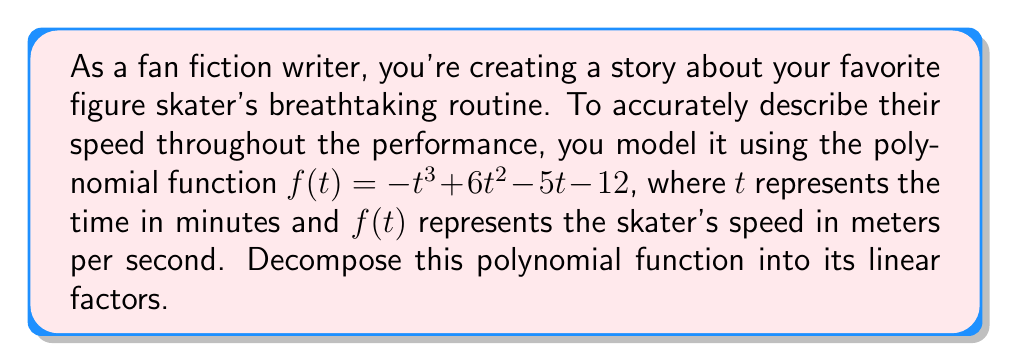Can you answer this question? To decompose the polynomial function $f(t) = -t^3 + 6t^2 - 5t - 12$ into its linear factors, we'll follow these steps:

1) First, let's check if there are any rational roots using the rational root theorem. The possible rational roots are the factors of the constant term: $\pm 1, \pm 2, \pm 3, \pm 4, \pm 6, \pm 12$.

2) Testing these values, we find that $t = 4$ is a root of the polynomial. So $(t - 4)$ is a factor.

3) We can use polynomial long division to divide $f(t)$ by $(t - 4)$:

   $$-t^3 + 6t^2 - 5t - 12 = (t - 4)(-t^2 + 2t + 3)$$

4) Now we need to factor the quadratic $-t^2 + 2t + 3$. We can do this by finding its roots:

   $$t = \frac{-b \pm \sqrt{b^2 - 4ac}}{2a} = \frac{-2 \pm \sqrt{4 + 12}}{-2} = \frac{-2 \pm \sqrt{16}}{-2} = \frac{-2 \pm 4}{-2}$$

5) This gives us the roots $t = 3$ and $t = -1$. Therefore, $-t^2 + 2t + 3 = -(t - 3)(t + 1)$.

6) Putting it all together:

   $$f(t) = -t^3 + 6t^2 - 5t - 12 = -(t - 4)(t - 3)(t + 1)$$

Thus, we have decomposed the polynomial into its linear factors.
Answer: $f(t) = -(t - 4)(t - 3)(t + 1)$ 